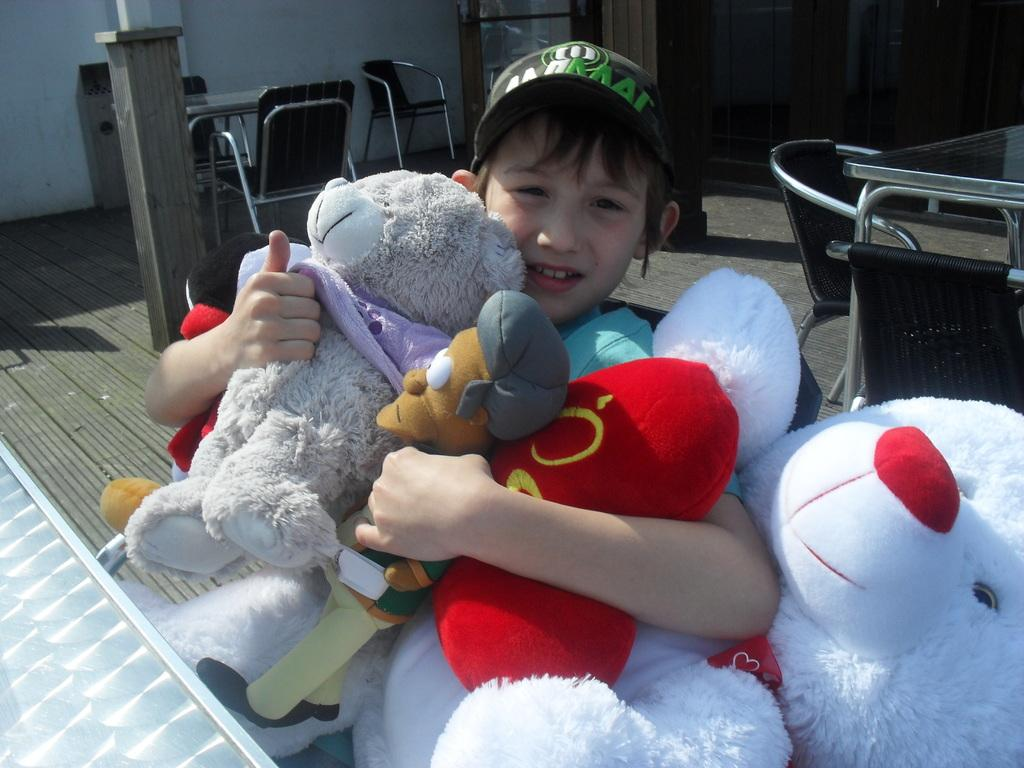Who is the main subject in the image? There is a boy in the image. What is the boy wearing on his head? The boy is wearing a cap. What is the boy holding in his hands? The boy is holding toys in his hands. What type of furniture can be seen in the background of the image? There are chairs and tables on the floor in the background of the image. What is visible on the wall in the background of the image? There is a wall visible in the background of the image, and some objects are present on it. What idea does the boy have for improving the bed in the image? There is no bed present in the image, so it is not possible to discuss any ideas for improving it. 